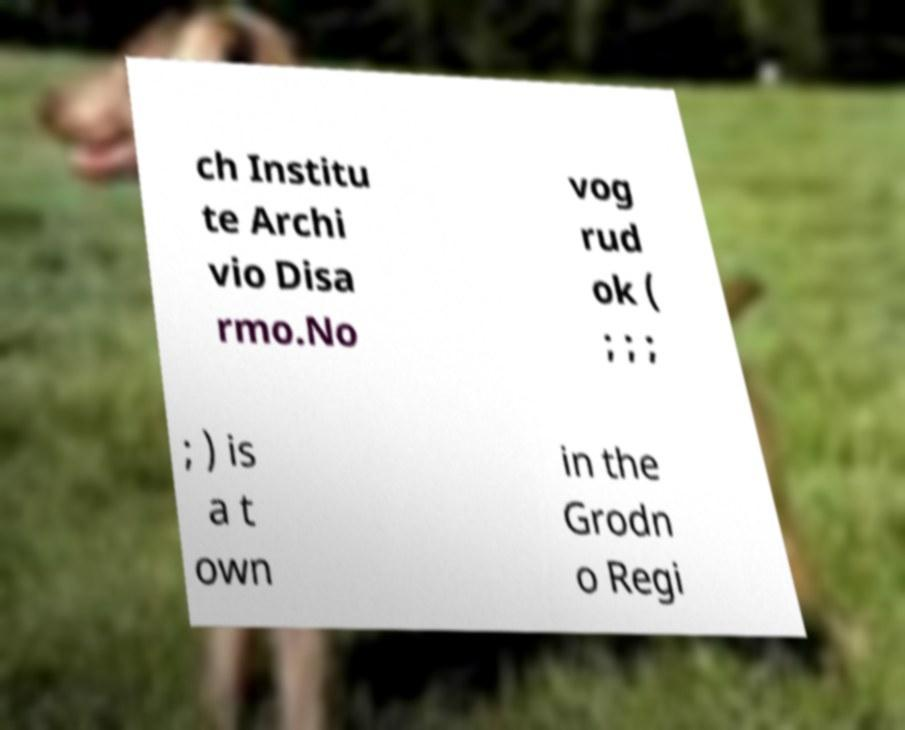Can you accurately transcribe the text from the provided image for me? ch Institu te Archi vio Disa rmo.No vog rud ok ( ; ; ; ; ) is a t own in the Grodn o Regi 